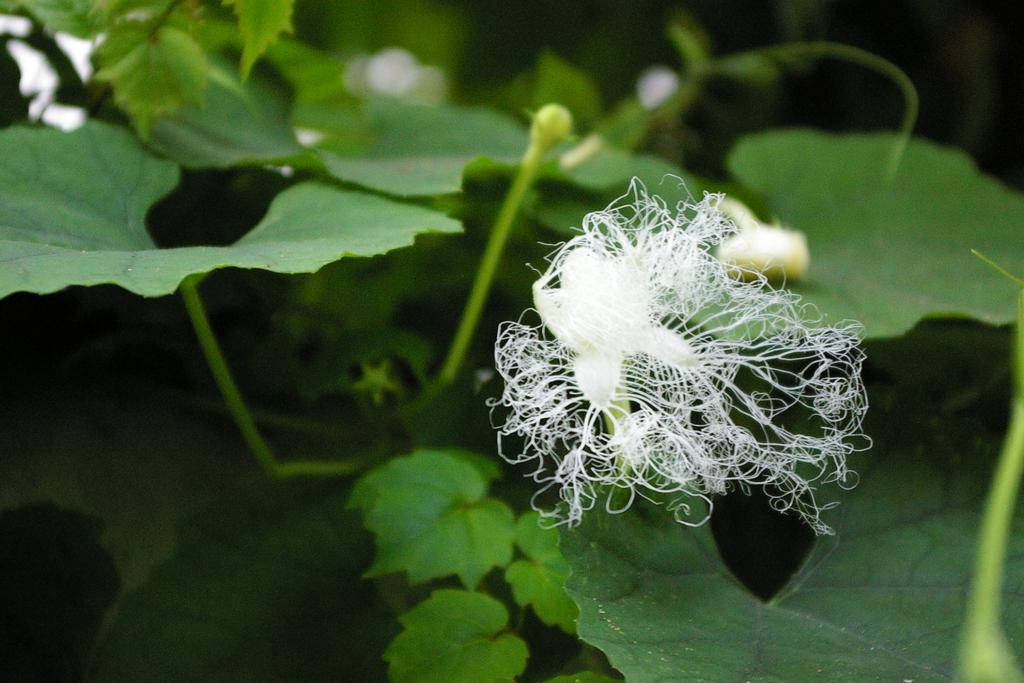What type of living organisms can be seen in the image? There are flowers and buds to a plant visible in the image. Can you describe the stage of growth for the plants in the image? The buds indicate that the plants are in the early stages of growth. What can be seen in the background of the image? There are plants visible in the background of the image. Who is the representative of the field in the image? There is no person or representative present in the image; it features flowers and plants. What is the thumb doing in the image? There is no thumb or any body part visible in the image. 